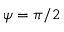Convert formula to latex. <formula><loc_0><loc_0><loc_500><loc_500>\psi = \pi / 2</formula> 